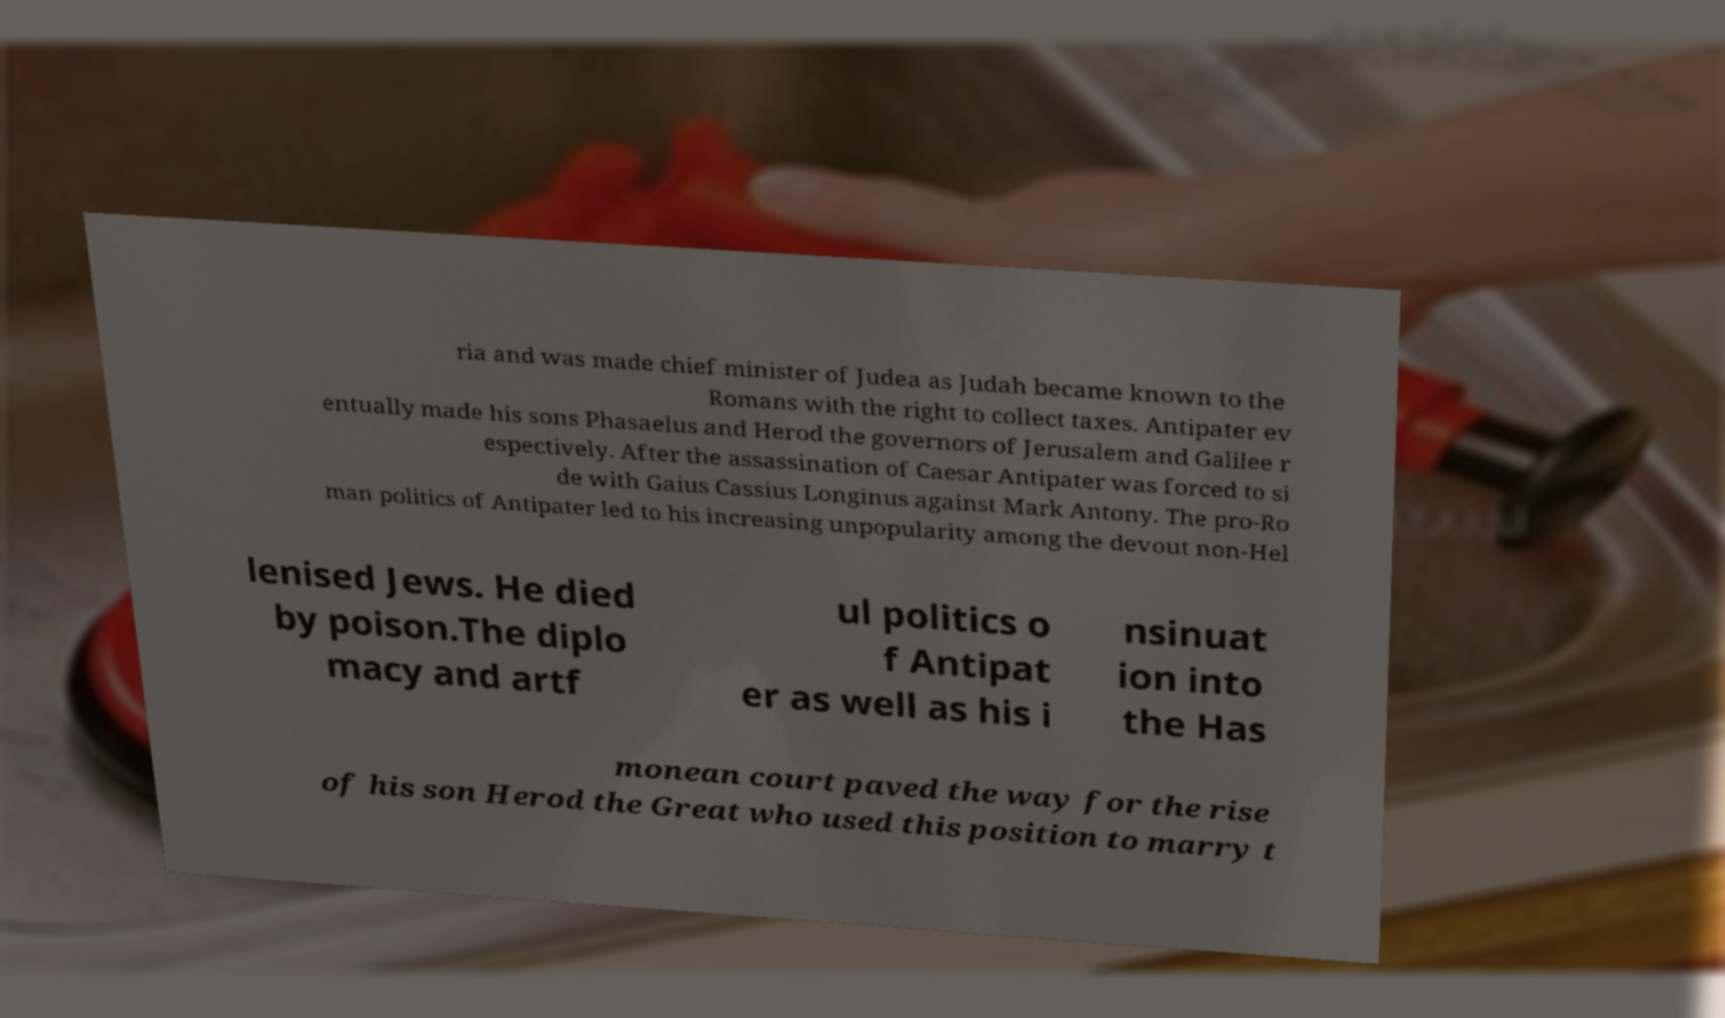Please identify and transcribe the text found in this image. ria and was made chief minister of Judea as Judah became known to the Romans with the right to collect taxes. Antipater ev entually made his sons Phasaelus and Herod the governors of Jerusalem and Galilee r espectively. After the assassination of Caesar Antipater was forced to si de with Gaius Cassius Longinus against Mark Antony. The pro-Ro man politics of Antipater led to his increasing unpopularity among the devout non-Hel lenised Jews. He died by poison.The diplo macy and artf ul politics o f Antipat er as well as his i nsinuat ion into the Has monean court paved the way for the rise of his son Herod the Great who used this position to marry t 